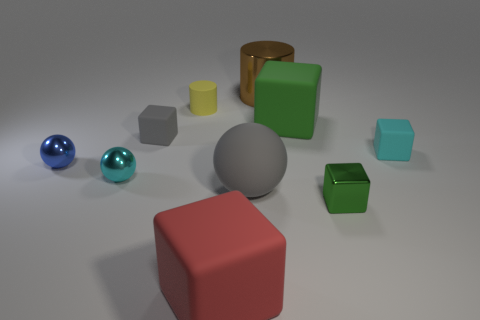Subtract all large cubes. How many cubes are left? 3 Subtract all yellow cylinders. How many green blocks are left? 2 Subtract all cyan balls. How many balls are left? 2 Subtract all purple balls. Subtract all brown blocks. How many balls are left? 3 Subtract all green things. Subtract all matte objects. How many objects are left? 2 Add 8 small blue balls. How many small blue balls are left? 9 Add 2 matte objects. How many matte objects exist? 8 Subtract 1 gray blocks. How many objects are left? 9 Subtract all spheres. How many objects are left? 7 